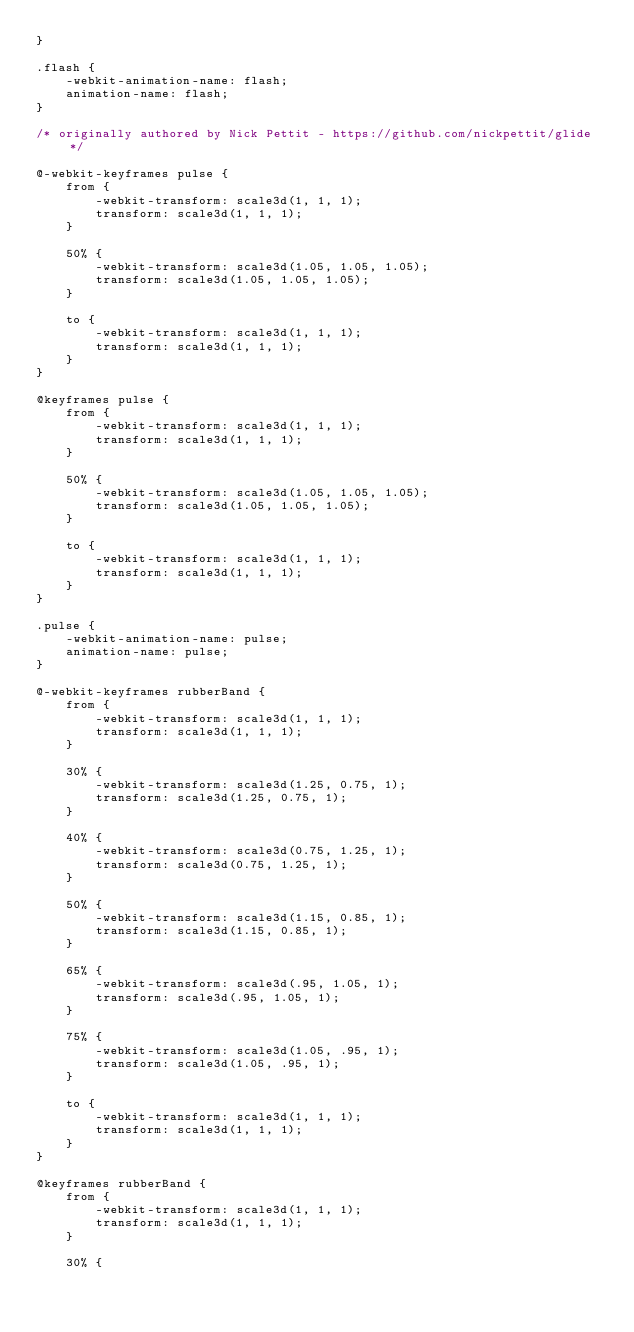<code> <loc_0><loc_0><loc_500><loc_500><_CSS_>}

.flash {
    -webkit-animation-name: flash;
    animation-name: flash;
}

/* originally authored by Nick Pettit - https://github.com/nickpettit/glide */

@-webkit-keyframes pulse {
    from {
        -webkit-transform: scale3d(1, 1, 1);
        transform: scale3d(1, 1, 1);
    }

    50% {
        -webkit-transform: scale3d(1.05, 1.05, 1.05);
        transform: scale3d(1.05, 1.05, 1.05);
    }

    to {
        -webkit-transform: scale3d(1, 1, 1);
        transform: scale3d(1, 1, 1);
    }
}

@keyframes pulse {
    from {
        -webkit-transform: scale3d(1, 1, 1);
        transform: scale3d(1, 1, 1);
    }

    50% {
        -webkit-transform: scale3d(1.05, 1.05, 1.05);
        transform: scale3d(1.05, 1.05, 1.05);
    }

    to {
        -webkit-transform: scale3d(1, 1, 1);
        transform: scale3d(1, 1, 1);
    }
}

.pulse {
    -webkit-animation-name: pulse;
    animation-name: pulse;
}

@-webkit-keyframes rubberBand {
    from {
        -webkit-transform: scale3d(1, 1, 1);
        transform: scale3d(1, 1, 1);
    }

    30% {
        -webkit-transform: scale3d(1.25, 0.75, 1);
        transform: scale3d(1.25, 0.75, 1);
    }

    40% {
        -webkit-transform: scale3d(0.75, 1.25, 1);
        transform: scale3d(0.75, 1.25, 1);
    }

    50% {
        -webkit-transform: scale3d(1.15, 0.85, 1);
        transform: scale3d(1.15, 0.85, 1);
    }

    65% {
        -webkit-transform: scale3d(.95, 1.05, 1);
        transform: scale3d(.95, 1.05, 1);
    }

    75% {
        -webkit-transform: scale3d(1.05, .95, 1);
        transform: scale3d(1.05, .95, 1);
    }

    to {
        -webkit-transform: scale3d(1, 1, 1);
        transform: scale3d(1, 1, 1);
    }
}

@keyframes rubberBand {
    from {
        -webkit-transform: scale3d(1, 1, 1);
        transform: scale3d(1, 1, 1);
    }

    30% {</code> 